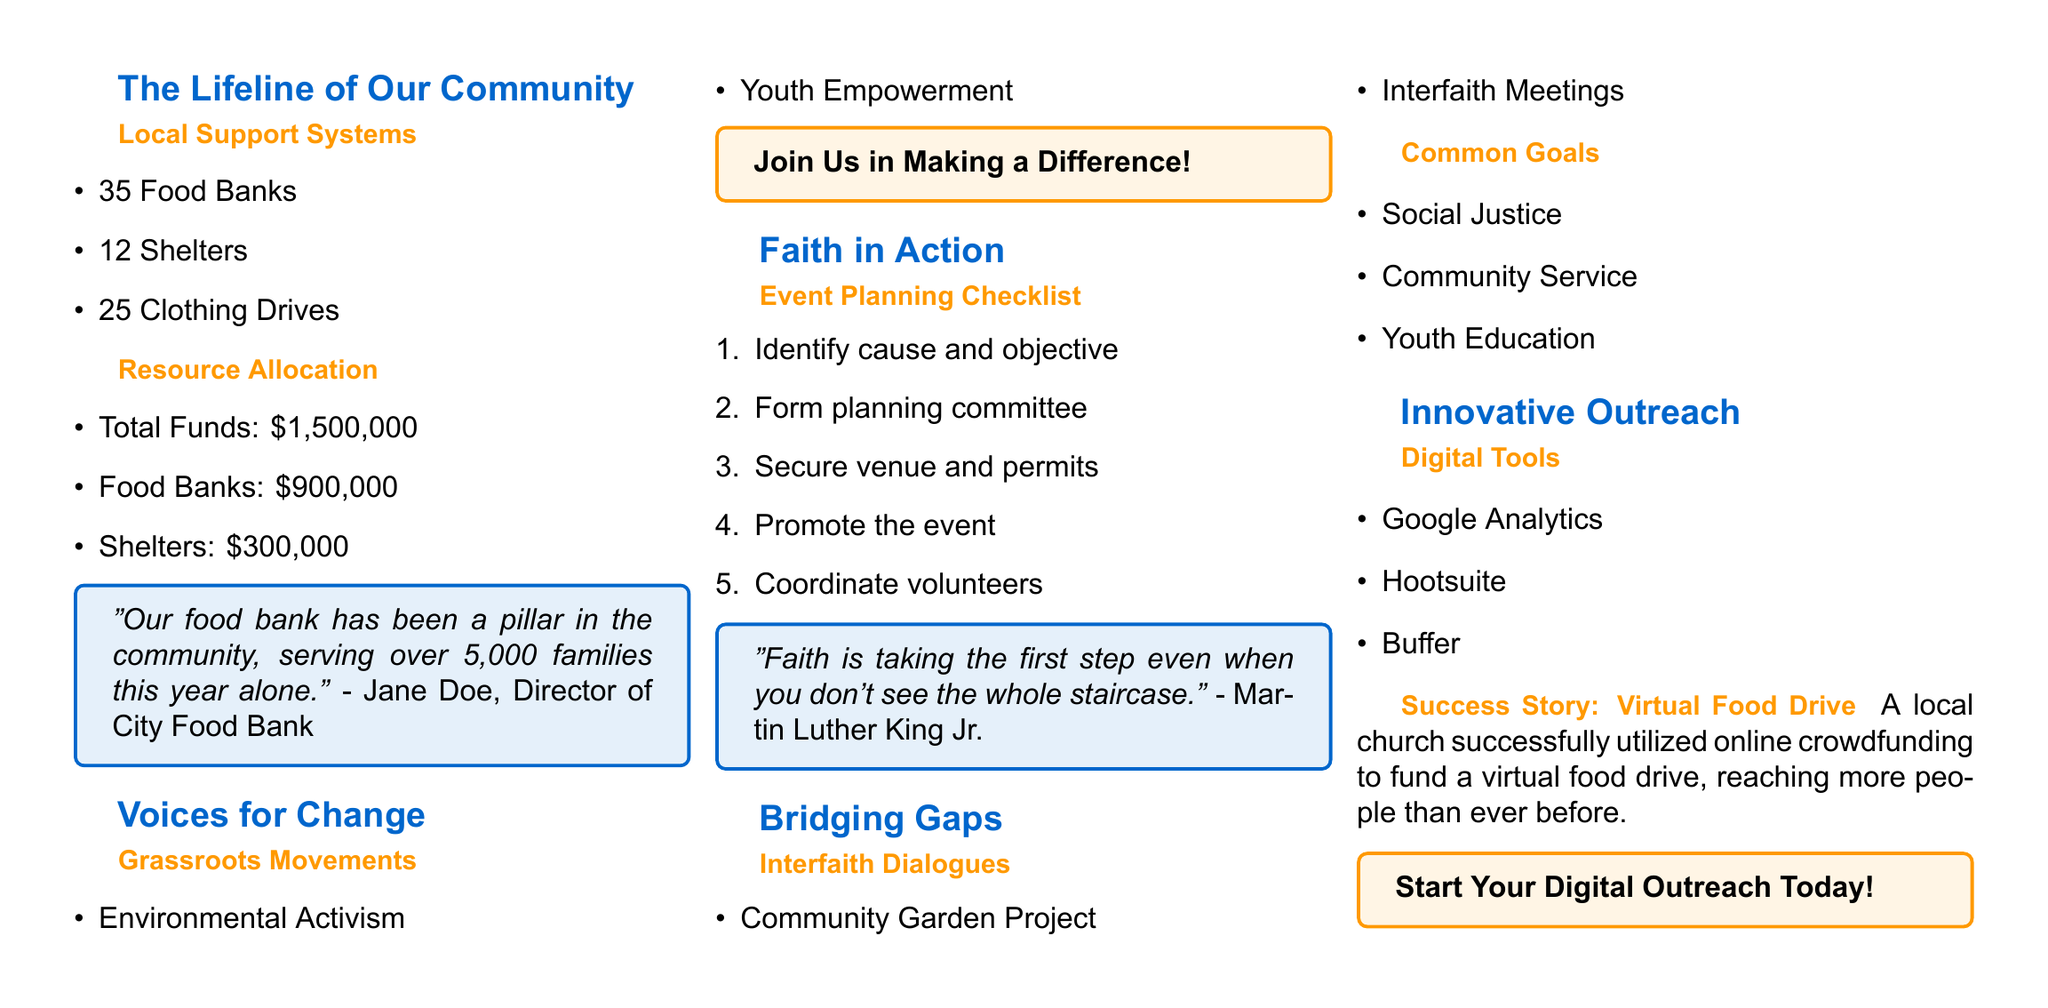What is the total number of food banks? The document lists 35 food banks as part of local support systems.
Answer: 35 How much funding was allocated to food banks? The document specifies that $900,000 was allocated to food banks.
Answer: $900,000 Who is the director of the City Food Bank? The quote in the document is attributed to Jane Doe, who is the Director of City Food Bank.
Answer: Jane Doe Which grassroots movement is mentioned under "Voices for Change"? The document mentions environmental activism as one of the grassroots movements.
Answer: Environmental Activism What is the first step in the event planning checklist? The first step listed in the checklist is to identify the cause and objective of the event.
Answer: Identify cause and objective What is the common goal related to youth in the interfaith dialogues section? The document mentions youth education as a common goal.
Answer: Youth Education What digital tool is listed for analytics? Google Analytics is one of the digital tools mentioned for outreach.
Answer: Google Analytics What innovative outreach success story is highlighted? The document highlights a virtual food drive as a successful innovative outreach.
Answer: Virtual Food Drive 